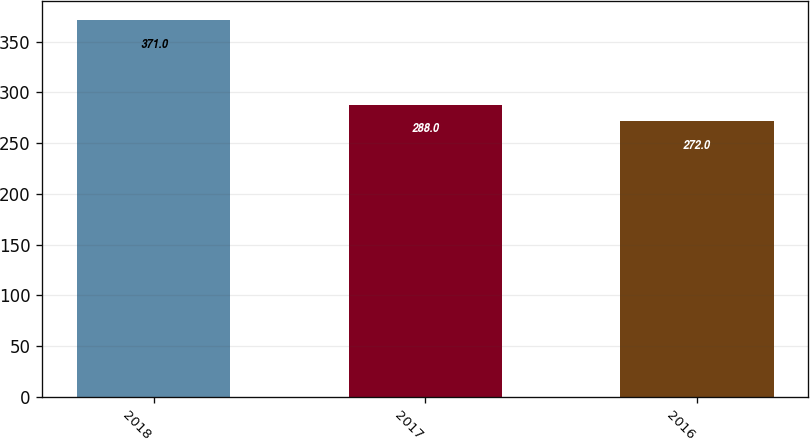Convert chart to OTSL. <chart><loc_0><loc_0><loc_500><loc_500><bar_chart><fcel>2018<fcel>2017<fcel>2016<nl><fcel>371<fcel>288<fcel>272<nl></chart> 